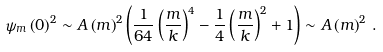<formula> <loc_0><loc_0><loc_500><loc_500>\psi _ { m } \left ( 0 \right ) ^ { 2 } \sim A \left ( m \right ) ^ { 2 } \left ( { \frac { 1 } { 6 4 } \left ( { \frac { m } { k } } \right ) ^ { 4 } - \frac { 1 } { 4 } \left ( { \frac { m } { k } } \right ) ^ { 2 } + 1 } \right ) \sim A \left ( m \right ) ^ { 2 } \, .</formula> 